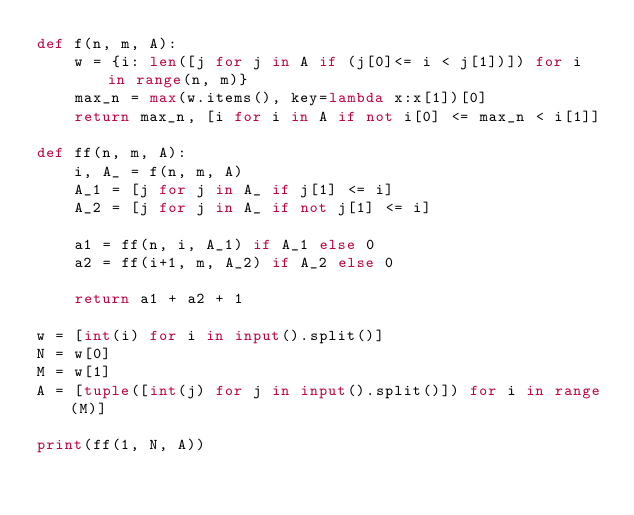Convert code to text. <code><loc_0><loc_0><loc_500><loc_500><_Python_>def f(n, m, A):
    w = {i: len([j for j in A if (j[0]<= i < j[1])]) for i in range(n, m)}
    max_n = max(w.items(), key=lambda x:x[1])[0]
    return max_n, [i for i in A if not i[0] <= max_n < i[1]]

def ff(n, m, A):
    i, A_ = f(n, m, A)
    A_1 = [j for j in A_ if j[1] <= i]
    A_2 = [j for j in A_ if not j[1] <= i]

    a1 = ff(n, i, A_1) if A_1 else 0
    a2 = ff(i+1, m, A_2) if A_2 else 0

    return a1 + a2 + 1

w = [int(i) for i in input().split()]
N = w[0]
M = w[1]
A = [tuple([int(j) for j in input().split()]) for i in range(M)]

print(ff(1, N, A))
</code> 